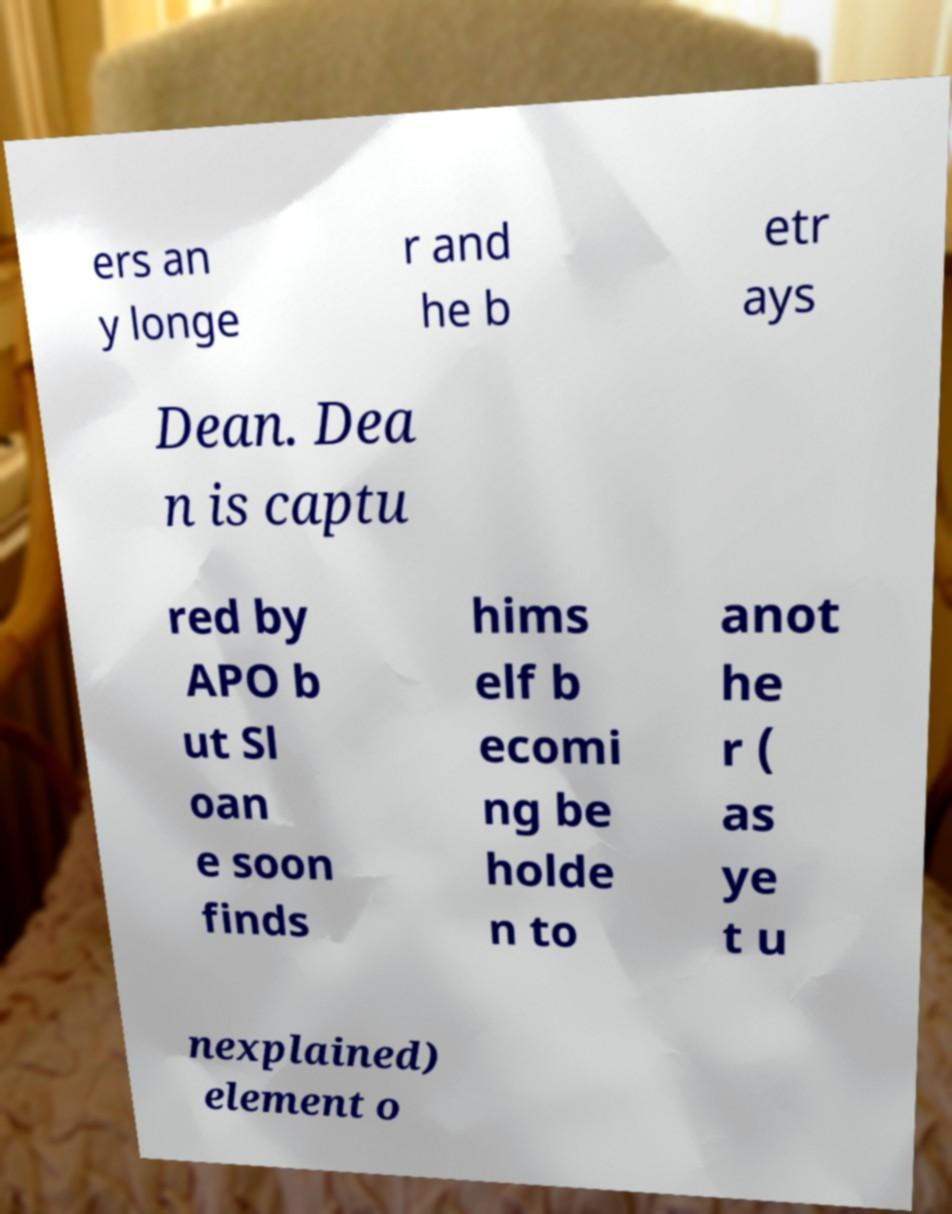What messages or text are displayed in this image? I need them in a readable, typed format. ers an y longe r and he b etr ays Dean. Dea n is captu red by APO b ut Sl oan e soon finds hims elf b ecomi ng be holde n to anot he r ( as ye t u nexplained) element o 